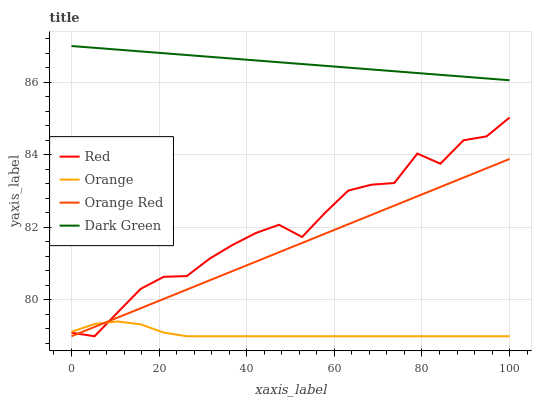Does Orange have the minimum area under the curve?
Answer yes or no. Yes. Does Dark Green have the maximum area under the curve?
Answer yes or no. Yes. Does Orange Red have the minimum area under the curve?
Answer yes or no. No. Does Orange Red have the maximum area under the curve?
Answer yes or no. No. Is Orange Red the smoothest?
Answer yes or no. Yes. Is Red the roughest?
Answer yes or no. Yes. Is Red the smoothest?
Answer yes or no. No. Is Orange Red the roughest?
Answer yes or no. No. Does Orange have the lowest value?
Answer yes or no. Yes. Does Dark Green have the lowest value?
Answer yes or no. No. Does Dark Green have the highest value?
Answer yes or no. Yes. Does Orange Red have the highest value?
Answer yes or no. No. Is Orange Red less than Dark Green?
Answer yes or no. Yes. Is Dark Green greater than Orange?
Answer yes or no. Yes. Does Red intersect Orange Red?
Answer yes or no. Yes. Is Red less than Orange Red?
Answer yes or no. No. Is Red greater than Orange Red?
Answer yes or no. No. Does Orange Red intersect Dark Green?
Answer yes or no. No. 